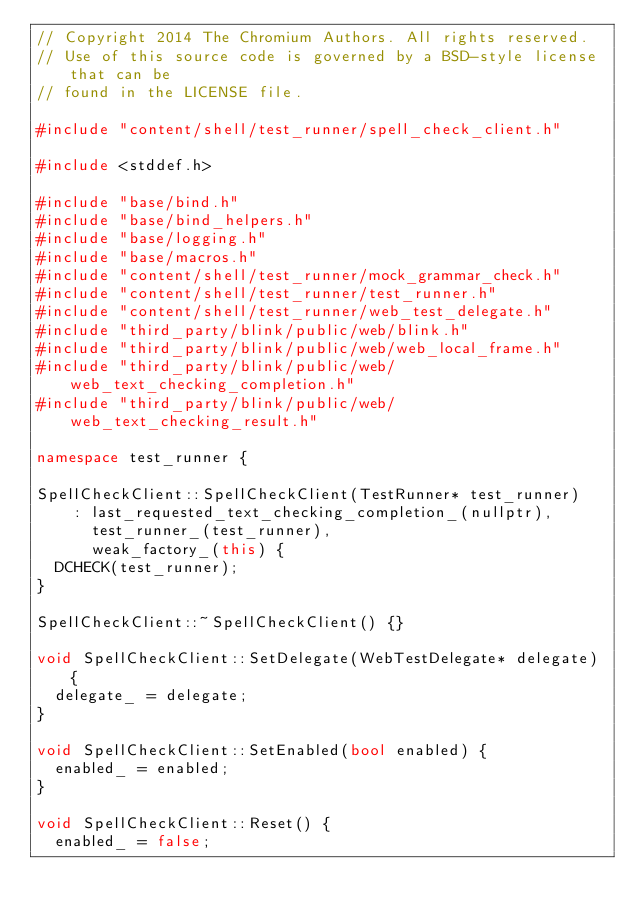<code> <loc_0><loc_0><loc_500><loc_500><_C++_>// Copyright 2014 The Chromium Authors. All rights reserved.
// Use of this source code is governed by a BSD-style license that can be
// found in the LICENSE file.

#include "content/shell/test_runner/spell_check_client.h"

#include <stddef.h>

#include "base/bind.h"
#include "base/bind_helpers.h"
#include "base/logging.h"
#include "base/macros.h"
#include "content/shell/test_runner/mock_grammar_check.h"
#include "content/shell/test_runner/test_runner.h"
#include "content/shell/test_runner/web_test_delegate.h"
#include "third_party/blink/public/web/blink.h"
#include "third_party/blink/public/web/web_local_frame.h"
#include "third_party/blink/public/web/web_text_checking_completion.h"
#include "third_party/blink/public/web/web_text_checking_result.h"

namespace test_runner {

SpellCheckClient::SpellCheckClient(TestRunner* test_runner)
    : last_requested_text_checking_completion_(nullptr),
      test_runner_(test_runner),
      weak_factory_(this) {
  DCHECK(test_runner);
}

SpellCheckClient::~SpellCheckClient() {}

void SpellCheckClient::SetDelegate(WebTestDelegate* delegate) {
  delegate_ = delegate;
}

void SpellCheckClient::SetEnabled(bool enabled) {
  enabled_ = enabled;
}

void SpellCheckClient::Reset() {
  enabled_ = false;</code> 